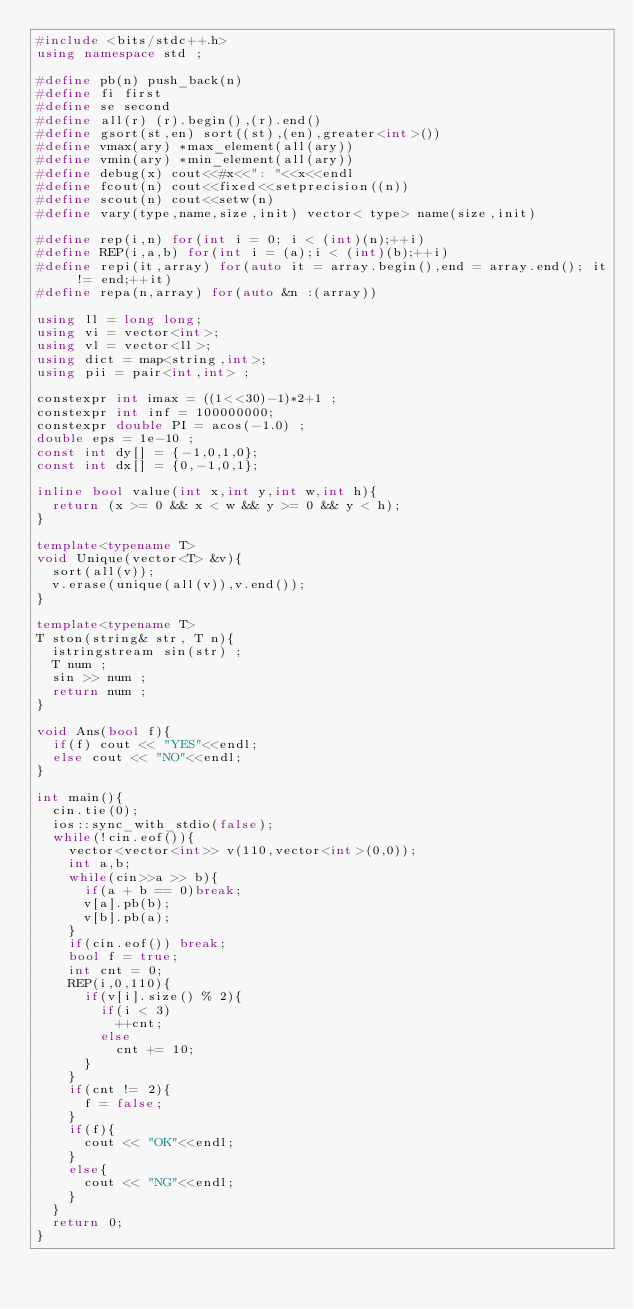Convert code to text. <code><loc_0><loc_0><loc_500><loc_500><_C++_>#include <bits/stdc++.h>
using namespace std ;

#define pb(n) push_back(n)
#define fi first
#define se second
#define all(r) (r).begin(),(r).end()
#define gsort(st,en) sort((st),(en),greater<int>())
#define vmax(ary) *max_element(all(ary))
#define vmin(ary) *min_element(all(ary))
#define debug(x) cout<<#x<<": "<<x<<endl
#define fcout(n) cout<<fixed<<setprecision((n))
#define scout(n) cout<<setw(n)
#define vary(type,name,size,init) vector< type> name(size,init)

#define rep(i,n) for(int i = 0; i < (int)(n);++i)
#define REP(i,a,b) for(int i = (a);i < (int)(b);++i)
#define repi(it,array) for(auto it = array.begin(),end = array.end(); it != end;++it)
#define repa(n,array) for(auto &n :(array))

using ll = long long;
using vi = vector<int>;
using vl = vector<ll>;
using dict = map<string,int>;
using pii = pair<int,int> ;

constexpr int imax = ((1<<30)-1)*2+1 ;
constexpr int inf = 100000000;
constexpr double PI = acos(-1.0) ;
double eps = 1e-10 ;
const int dy[] = {-1,0,1,0};
const int dx[] = {0,-1,0,1};

inline bool value(int x,int y,int w,int h){
  return (x >= 0 && x < w && y >= 0 && y < h);
}

template<typename T>
void Unique(vector<T> &v){
  sort(all(v));
  v.erase(unique(all(v)),v.end());
}

template<typename T>
T ston(string& str, T n){
  istringstream sin(str) ;
  T num ;
  sin >> num ;
  return num ;
}

void Ans(bool f){
  if(f) cout << "YES"<<endl;
  else cout << "NO"<<endl;
}

int main(){
  cin.tie(0);
  ios::sync_with_stdio(false);
  while(!cin.eof()){
    vector<vector<int>> v(110,vector<int>(0,0));
    int a,b;
    while(cin>>a >> b){
      if(a + b == 0)break;
      v[a].pb(b);
      v[b].pb(a);
    }
    if(cin.eof()) break;
    bool f = true;
    int cnt = 0;
    REP(i,0,110){
      if(v[i].size() % 2){
        if(i < 3)
          ++cnt;
        else
          cnt += 10;
      }
    }
    if(cnt != 2){
      f = false;
    }
    if(f){
      cout << "OK"<<endl;
    }
    else{
      cout << "NG"<<endl;
    }
  }
  return 0;
}</code> 